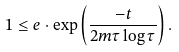<formula> <loc_0><loc_0><loc_500><loc_500>1 \leq e \cdot \exp \left ( \frac { - t } { 2 m \tau \log \tau } \right ) .</formula> 